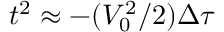<formula> <loc_0><loc_0><loc_500><loc_500>t ^ { 2 } \approx - ( V _ { 0 } ^ { 2 } / 2 ) \Delta \tau</formula> 